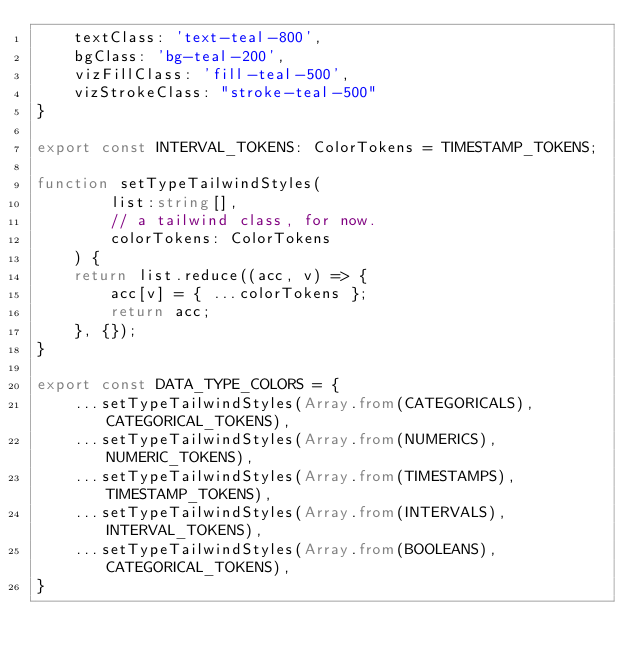Convert code to text. <code><loc_0><loc_0><loc_500><loc_500><_TypeScript_>    textClass: 'text-teal-800',
    bgClass: 'bg-teal-200',
    vizFillClass: 'fill-teal-500',
    vizStrokeClass: "stroke-teal-500"
}

export const INTERVAL_TOKENS: ColorTokens = TIMESTAMP_TOKENS;

function setTypeTailwindStyles(
        list:string[], 
        // a tailwind class, for now.
        colorTokens: ColorTokens
    ) {
    return list.reduce((acc, v) => {
        acc[v] = { ...colorTokens };
        return acc;
    }, {});
}

export const DATA_TYPE_COLORS = {
    ...setTypeTailwindStyles(Array.from(CATEGORICALS), CATEGORICAL_TOKENS),
    ...setTypeTailwindStyles(Array.from(NUMERICS), NUMERIC_TOKENS),
    ...setTypeTailwindStyles(Array.from(TIMESTAMPS), TIMESTAMP_TOKENS),
    ...setTypeTailwindStyles(Array.from(INTERVALS), INTERVAL_TOKENS),
    ...setTypeTailwindStyles(Array.from(BOOLEANS), CATEGORICAL_TOKENS),
}</code> 